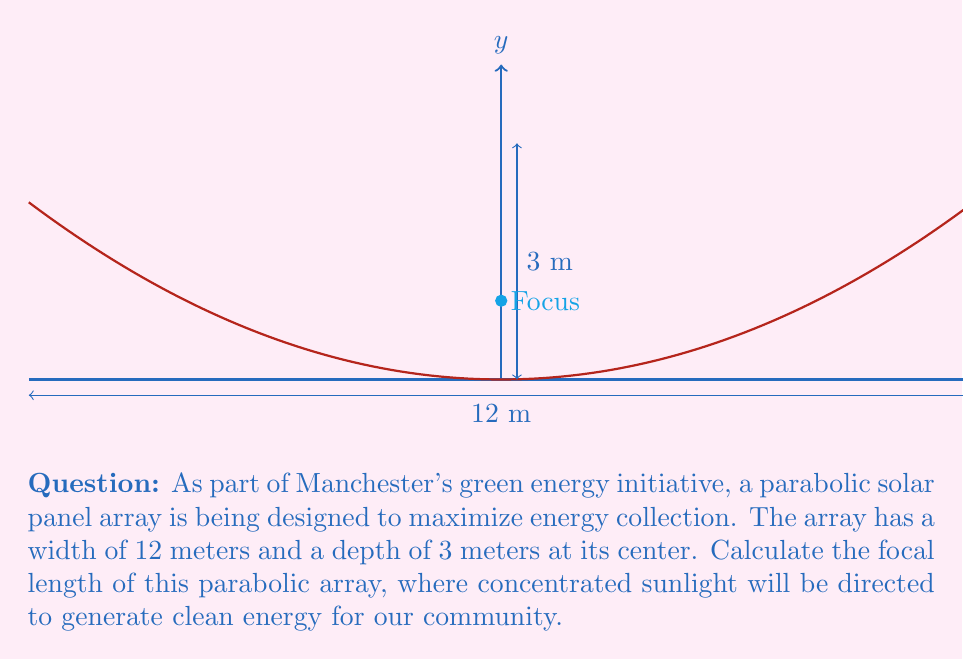Teach me how to tackle this problem. Let's approach this step-by-step:

1) The general equation of a parabola with vertex at the origin is:
   $$y = \frac{1}{4p}x^2$$
   where $p$ is the focal length.

2) We know the width (12 m) and depth (3 m) of the parabola. The width gives us the x-coordinate, and the depth gives us the y-coordinate of a point on the parabola.

3) Since the parabola is symmetrical, we can use half the width (6 m) for our x-coordinate:
   $$(x, y) = (6, 3)$$

4) Substituting these values into the general equation:
   $$3 = \frac{1}{4p}(6^2)$$

5) Simplify:
   $$3 = \frac{36}{4p}$$

6) Multiply both sides by $4p$:
   $$12p = 36$$

7) Divide both sides by 12:
   $$p = 3$$

Therefore, the focal length of the parabolic solar panel array is 3 meters.
Answer: $3$ meters 